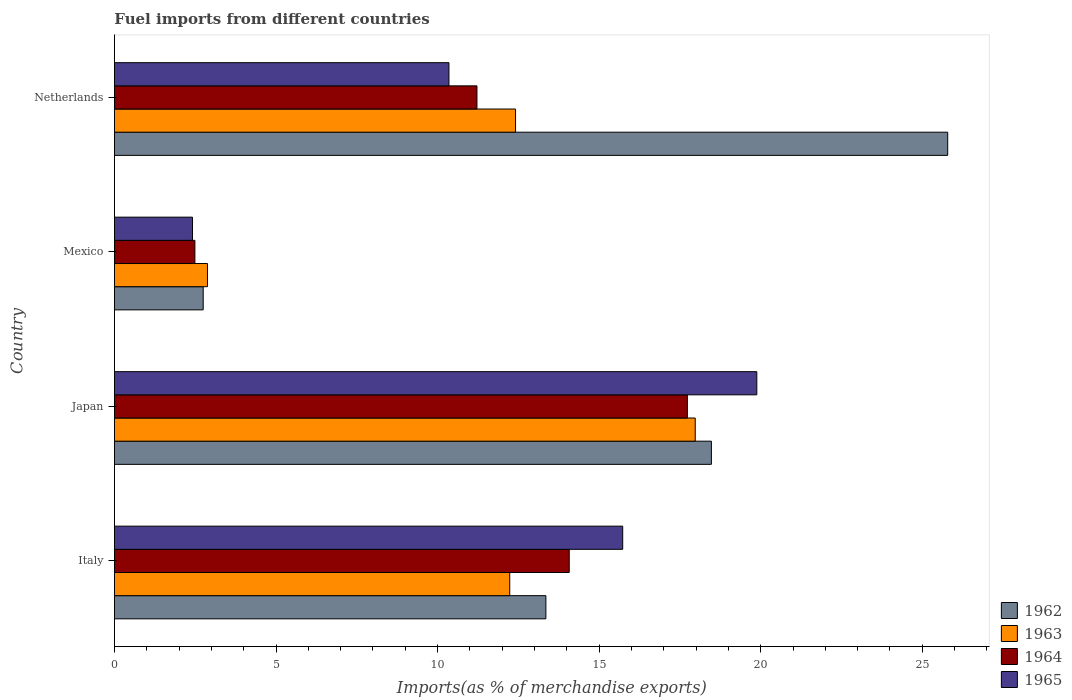What is the percentage of imports to different countries in 1964 in Netherlands?
Offer a very short reply. 11.22. Across all countries, what is the maximum percentage of imports to different countries in 1962?
Your answer should be compact. 25.79. Across all countries, what is the minimum percentage of imports to different countries in 1962?
Offer a terse response. 2.75. In which country was the percentage of imports to different countries in 1963 minimum?
Your answer should be compact. Mexico. What is the total percentage of imports to different countries in 1965 in the graph?
Provide a short and direct response. 48.38. What is the difference between the percentage of imports to different countries in 1963 in Italy and that in Japan?
Keep it short and to the point. -5.74. What is the difference between the percentage of imports to different countries in 1963 in Italy and the percentage of imports to different countries in 1965 in Netherlands?
Your answer should be compact. 1.88. What is the average percentage of imports to different countries in 1962 per country?
Offer a terse response. 15.09. What is the difference between the percentage of imports to different countries in 1963 and percentage of imports to different countries in 1962 in Netherlands?
Make the answer very short. -13.37. What is the ratio of the percentage of imports to different countries in 1962 in Italy to that in Japan?
Give a very brief answer. 0.72. What is the difference between the highest and the second highest percentage of imports to different countries in 1965?
Your answer should be very brief. 4.15. What is the difference between the highest and the lowest percentage of imports to different countries in 1965?
Provide a succinct answer. 17.46. Is the sum of the percentage of imports to different countries in 1963 in Japan and Netherlands greater than the maximum percentage of imports to different countries in 1964 across all countries?
Your answer should be compact. Yes. What does the 4th bar from the top in Japan represents?
Provide a succinct answer. 1962. What does the 3rd bar from the bottom in Italy represents?
Give a very brief answer. 1964. Is it the case that in every country, the sum of the percentage of imports to different countries in 1964 and percentage of imports to different countries in 1962 is greater than the percentage of imports to different countries in 1965?
Provide a succinct answer. Yes. How many bars are there?
Offer a very short reply. 16. Are all the bars in the graph horizontal?
Offer a very short reply. Yes. What is the difference between two consecutive major ticks on the X-axis?
Make the answer very short. 5. Are the values on the major ticks of X-axis written in scientific E-notation?
Provide a short and direct response. No. What is the title of the graph?
Your response must be concise. Fuel imports from different countries. Does "1997" appear as one of the legend labels in the graph?
Provide a succinct answer. No. What is the label or title of the X-axis?
Offer a terse response. Imports(as % of merchandise exports). What is the label or title of the Y-axis?
Ensure brevity in your answer.  Country. What is the Imports(as % of merchandise exports) of 1962 in Italy?
Make the answer very short. 13.35. What is the Imports(as % of merchandise exports) in 1963 in Italy?
Offer a terse response. 12.23. What is the Imports(as % of merchandise exports) in 1964 in Italy?
Your answer should be very brief. 14.07. What is the Imports(as % of merchandise exports) in 1965 in Italy?
Offer a terse response. 15.73. What is the Imports(as % of merchandise exports) in 1962 in Japan?
Your answer should be compact. 18.47. What is the Imports(as % of merchandise exports) in 1963 in Japan?
Provide a short and direct response. 17.97. What is the Imports(as % of merchandise exports) in 1964 in Japan?
Offer a very short reply. 17.73. What is the Imports(as % of merchandise exports) in 1965 in Japan?
Keep it short and to the point. 19.88. What is the Imports(as % of merchandise exports) of 1962 in Mexico?
Your answer should be very brief. 2.75. What is the Imports(as % of merchandise exports) in 1963 in Mexico?
Your answer should be very brief. 2.88. What is the Imports(as % of merchandise exports) in 1964 in Mexico?
Your answer should be compact. 2.49. What is the Imports(as % of merchandise exports) of 1965 in Mexico?
Make the answer very short. 2.42. What is the Imports(as % of merchandise exports) in 1962 in Netherlands?
Provide a succinct answer. 25.79. What is the Imports(as % of merchandise exports) of 1963 in Netherlands?
Offer a terse response. 12.41. What is the Imports(as % of merchandise exports) in 1964 in Netherlands?
Keep it short and to the point. 11.22. What is the Imports(as % of merchandise exports) of 1965 in Netherlands?
Your answer should be very brief. 10.35. Across all countries, what is the maximum Imports(as % of merchandise exports) of 1962?
Ensure brevity in your answer.  25.79. Across all countries, what is the maximum Imports(as % of merchandise exports) in 1963?
Your response must be concise. 17.97. Across all countries, what is the maximum Imports(as % of merchandise exports) in 1964?
Give a very brief answer. 17.73. Across all countries, what is the maximum Imports(as % of merchandise exports) of 1965?
Your response must be concise. 19.88. Across all countries, what is the minimum Imports(as % of merchandise exports) in 1962?
Offer a terse response. 2.75. Across all countries, what is the minimum Imports(as % of merchandise exports) in 1963?
Keep it short and to the point. 2.88. Across all countries, what is the minimum Imports(as % of merchandise exports) in 1964?
Make the answer very short. 2.49. Across all countries, what is the minimum Imports(as % of merchandise exports) in 1965?
Your answer should be very brief. 2.42. What is the total Imports(as % of merchandise exports) in 1962 in the graph?
Provide a short and direct response. 60.36. What is the total Imports(as % of merchandise exports) in 1963 in the graph?
Offer a very short reply. 45.5. What is the total Imports(as % of merchandise exports) in 1964 in the graph?
Offer a very short reply. 45.52. What is the total Imports(as % of merchandise exports) in 1965 in the graph?
Offer a very short reply. 48.38. What is the difference between the Imports(as % of merchandise exports) of 1962 in Italy and that in Japan?
Ensure brevity in your answer.  -5.12. What is the difference between the Imports(as % of merchandise exports) of 1963 in Italy and that in Japan?
Offer a very short reply. -5.74. What is the difference between the Imports(as % of merchandise exports) in 1964 in Italy and that in Japan?
Your answer should be very brief. -3.66. What is the difference between the Imports(as % of merchandise exports) in 1965 in Italy and that in Japan?
Your answer should be compact. -4.15. What is the difference between the Imports(as % of merchandise exports) in 1962 in Italy and that in Mexico?
Make the answer very short. 10.61. What is the difference between the Imports(as % of merchandise exports) of 1963 in Italy and that in Mexico?
Give a very brief answer. 9.36. What is the difference between the Imports(as % of merchandise exports) in 1964 in Italy and that in Mexico?
Provide a short and direct response. 11.58. What is the difference between the Imports(as % of merchandise exports) in 1965 in Italy and that in Mexico?
Give a very brief answer. 13.31. What is the difference between the Imports(as % of merchandise exports) of 1962 in Italy and that in Netherlands?
Offer a terse response. -12.44. What is the difference between the Imports(as % of merchandise exports) of 1963 in Italy and that in Netherlands?
Your answer should be very brief. -0.18. What is the difference between the Imports(as % of merchandise exports) of 1964 in Italy and that in Netherlands?
Your answer should be compact. 2.86. What is the difference between the Imports(as % of merchandise exports) in 1965 in Italy and that in Netherlands?
Make the answer very short. 5.38. What is the difference between the Imports(as % of merchandise exports) in 1962 in Japan and that in Mexico?
Your answer should be compact. 15.73. What is the difference between the Imports(as % of merchandise exports) of 1963 in Japan and that in Mexico?
Your response must be concise. 15.1. What is the difference between the Imports(as % of merchandise exports) of 1964 in Japan and that in Mexico?
Make the answer very short. 15.24. What is the difference between the Imports(as % of merchandise exports) in 1965 in Japan and that in Mexico?
Provide a succinct answer. 17.46. What is the difference between the Imports(as % of merchandise exports) in 1962 in Japan and that in Netherlands?
Make the answer very short. -7.31. What is the difference between the Imports(as % of merchandise exports) in 1963 in Japan and that in Netherlands?
Keep it short and to the point. 5.56. What is the difference between the Imports(as % of merchandise exports) of 1964 in Japan and that in Netherlands?
Offer a very short reply. 6.51. What is the difference between the Imports(as % of merchandise exports) of 1965 in Japan and that in Netherlands?
Offer a very short reply. 9.53. What is the difference between the Imports(as % of merchandise exports) in 1962 in Mexico and that in Netherlands?
Provide a short and direct response. -23.04. What is the difference between the Imports(as % of merchandise exports) in 1963 in Mexico and that in Netherlands?
Provide a short and direct response. -9.53. What is the difference between the Imports(as % of merchandise exports) in 1964 in Mexico and that in Netherlands?
Your answer should be very brief. -8.73. What is the difference between the Imports(as % of merchandise exports) of 1965 in Mexico and that in Netherlands?
Offer a terse response. -7.94. What is the difference between the Imports(as % of merchandise exports) of 1962 in Italy and the Imports(as % of merchandise exports) of 1963 in Japan?
Your answer should be very brief. -4.62. What is the difference between the Imports(as % of merchandise exports) in 1962 in Italy and the Imports(as % of merchandise exports) in 1964 in Japan?
Give a very brief answer. -4.38. What is the difference between the Imports(as % of merchandise exports) of 1962 in Italy and the Imports(as % of merchandise exports) of 1965 in Japan?
Make the answer very short. -6.53. What is the difference between the Imports(as % of merchandise exports) of 1963 in Italy and the Imports(as % of merchandise exports) of 1964 in Japan?
Ensure brevity in your answer.  -5.5. What is the difference between the Imports(as % of merchandise exports) of 1963 in Italy and the Imports(as % of merchandise exports) of 1965 in Japan?
Make the answer very short. -7.65. What is the difference between the Imports(as % of merchandise exports) in 1964 in Italy and the Imports(as % of merchandise exports) in 1965 in Japan?
Provide a succinct answer. -5.8. What is the difference between the Imports(as % of merchandise exports) of 1962 in Italy and the Imports(as % of merchandise exports) of 1963 in Mexico?
Keep it short and to the point. 10.47. What is the difference between the Imports(as % of merchandise exports) of 1962 in Italy and the Imports(as % of merchandise exports) of 1964 in Mexico?
Your answer should be very brief. 10.86. What is the difference between the Imports(as % of merchandise exports) in 1962 in Italy and the Imports(as % of merchandise exports) in 1965 in Mexico?
Your answer should be very brief. 10.94. What is the difference between the Imports(as % of merchandise exports) of 1963 in Italy and the Imports(as % of merchandise exports) of 1964 in Mexico?
Make the answer very short. 9.74. What is the difference between the Imports(as % of merchandise exports) in 1963 in Italy and the Imports(as % of merchandise exports) in 1965 in Mexico?
Give a very brief answer. 9.82. What is the difference between the Imports(as % of merchandise exports) in 1964 in Italy and the Imports(as % of merchandise exports) in 1965 in Mexico?
Offer a terse response. 11.66. What is the difference between the Imports(as % of merchandise exports) of 1962 in Italy and the Imports(as % of merchandise exports) of 1963 in Netherlands?
Provide a short and direct response. 0.94. What is the difference between the Imports(as % of merchandise exports) in 1962 in Italy and the Imports(as % of merchandise exports) in 1964 in Netherlands?
Make the answer very short. 2.13. What is the difference between the Imports(as % of merchandise exports) in 1962 in Italy and the Imports(as % of merchandise exports) in 1965 in Netherlands?
Your answer should be compact. 3. What is the difference between the Imports(as % of merchandise exports) in 1963 in Italy and the Imports(as % of merchandise exports) in 1964 in Netherlands?
Your answer should be very brief. 1.01. What is the difference between the Imports(as % of merchandise exports) of 1963 in Italy and the Imports(as % of merchandise exports) of 1965 in Netherlands?
Your answer should be very brief. 1.88. What is the difference between the Imports(as % of merchandise exports) in 1964 in Italy and the Imports(as % of merchandise exports) in 1965 in Netherlands?
Give a very brief answer. 3.72. What is the difference between the Imports(as % of merchandise exports) of 1962 in Japan and the Imports(as % of merchandise exports) of 1963 in Mexico?
Keep it short and to the point. 15.6. What is the difference between the Imports(as % of merchandise exports) in 1962 in Japan and the Imports(as % of merchandise exports) in 1964 in Mexico?
Your response must be concise. 15.98. What is the difference between the Imports(as % of merchandise exports) of 1962 in Japan and the Imports(as % of merchandise exports) of 1965 in Mexico?
Make the answer very short. 16.06. What is the difference between the Imports(as % of merchandise exports) in 1963 in Japan and the Imports(as % of merchandise exports) in 1964 in Mexico?
Give a very brief answer. 15.48. What is the difference between the Imports(as % of merchandise exports) of 1963 in Japan and the Imports(as % of merchandise exports) of 1965 in Mexico?
Your answer should be compact. 15.56. What is the difference between the Imports(as % of merchandise exports) in 1964 in Japan and the Imports(as % of merchandise exports) in 1965 in Mexico?
Offer a terse response. 15.32. What is the difference between the Imports(as % of merchandise exports) of 1962 in Japan and the Imports(as % of merchandise exports) of 1963 in Netherlands?
Provide a short and direct response. 6.06. What is the difference between the Imports(as % of merchandise exports) of 1962 in Japan and the Imports(as % of merchandise exports) of 1964 in Netherlands?
Your answer should be very brief. 7.25. What is the difference between the Imports(as % of merchandise exports) of 1962 in Japan and the Imports(as % of merchandise exports) of 1965 in Netherlands?
Offer a terse response. 8.12. What is the difference between the Imports(as % of merchandise exports) in 1963 in Japan and the Imports(as % of merchandise exports) in 1964 in Netherlands?
Your response must be concise. 6.76. What is the difference between the Imports(as % of merchandise exports) in 1963 in Japan and the Imports(as % of merchandise exports) in 1965 in Netherlands?
Your response must be concise. 7.62. What is the difference between the Imports(as % of merchandise exports) in 1964 in Japan and the Imports(as % of merchandise exports) in 1965 in Netherlands?
Your answer should be very brief. 7.38. What is the difference between the Imports(as % of merchandise exports) in 1962 in Mexico and the Imports(as % of merchandise exports) in 1963 in Netherlands?
Your answer should be very brief. -9.67. What is the difference between the Imports(as % of merchandise exports) in 1962 in Mexico and the Imports(as % of merchandise exports) in 1964 in Netherlands?
Offer a very short reply. -8.47. What is the difference between the Imports(as % of merchandise exports) in 1962 in Mexico and the Imports(as % of merchandise exports) in 1965 in Netherlands?
Your response must be concise. -7.61. What is the difference between the Imports(as % of merchandise exports) in 1963 in Mexico and the Imports(as % of merchandise exports) in 1964 in Netherlands?
Ensure brevity in your answer.  -8.34. What is the difference between the Imports(as % of merchandise exports) in 1963 in Mexico and the Imports(as % of merchandise exports) in 1965 in Netherlands?
Provide a succinct answer. -7.47. What is the difference between the Imports(as % of merchandise exports) in 1964 in Mexico and the Imports(as % of merchandise exports) in 1965 in Netherlands?
Keep it short and to the point. -7.86. What is the average Imports(as % of merchandise exports) of 1962 per country?
Offer a terse response. 15.09. What is the average Imports(as % of merchandise exports) in 1963 per country?
Provide a succinct answer. 11.38. What is the average Imports(as % of merchandise exports) of 1964 per country?
Offer a terse response. 11.38. What is the average Imports(as % of merchandise exports) in 1965 per country?
Give a very brief answer. 12.09. What is the difference between the Imports(as % of merchandise exports) of 1962 and Imports(as % of merchandise exports) of 1963 in Italy?
Make the answer very short. 1.12. What is the difference between the Imports(as % of merchandise exports) in 1962 and Imports(as % of merchandise exports) in 1964 in Italy?
Offer a terse response. -0.72. What is the difference between the Imports(as % of merchandise exports) in 1962 and Imports(as % of merchandise exports) in 1965 in Italy?
Keep it short and to the point. -2.38. What is the difference between the Imports(as % of merchandise exports) of 1963 and Imports(as % of merchandise exports) of 1964 in Italy?
Offer a terse response. -1.84. What is the difference between the Imports(as % of merchandise exports) in 1963 and Imports(as % of merchandise exports) in 1965 in Italy?
Your answer should be compact. -3.5. What is the difference between the Imports(as % of merchandise exports) of 1964 and Imports(as % of merchandise exports) of 1965 in Italy?
Your answer should be compact. -1.65. What is the difference between the Imports(as % of merchandise exports) in 1962 and Imports(as % of merchandise exports) in 1963 in Japan?
Your response must be concise. 0.5. What is the difference between the Imports(as % of merchandise exports) in 1962 and Imports(as % of merchandise exports) in 1964 in Japan?
Ensure brevity in your answer.  0.74. What is the difference between the Imports(as % of merchandise exports) in 1962 and Imports(as % of merchandise exports) in 1965 in Japan?
Your answer should be compact. -1.41. What is the difference between the Imports(as % of merchandise exports) of 1963 and Imports(as % of merchandise exports) of 1964 in Japan?
Provide a succinct answer. 0.24. What is the difference between the Imports(as % of merchandise exports) in 1963 and Imports(as % of merchandise exports) in 1965 in Japan?
Give a very brief answer. -1.91. What is the difference between the Imports(as % of merchandise exports) of 1964 and Imports(as % of merchandise exports) of 1965 in Japan?
Provide a succinct answer. -2.15. What is the difference between the Imports(as % of merchandise exports) in 1962 and Imports(as % of merchandise exports) in 1963 in Mexico?
Provide a succinct answer. -0.13. What is the difference between the Imports(as % of merchandise exports) of 1962 and Imports(as % of merchandise exports) of 1964 in Mexico?
Give a very brief answer. 0.26. What is the difference between the Imports(as % of merchandise exports) in 1962 and Imports(as % of merchandise exports) in 1965 in Mexico?
Ensure brevity in your answer.  0.33. What is the difference between the Imports(as % of merchandise exports) in 1963 and Imports(as % of merchandise exports) in 1964 in Mexico?
Provide a short and direct response. 0.39. What is the difference between the Imports(as % of merchandise exports) of 1963 and Imports(as % of merchandise exports) of 1965 in Mexico?
Ensure brevity in your answer.  0.46. What is the difference between the Imports(as % of merchandise exports) of 1964 and Imports(as % of merchandise exports) of 1965 in Mexico?
Provide a short and direct response. 0.07. What is the difference between the Imports(as % of merchandise exports) in 1962 and Imports(as % of merchandise exports) in 1963 in Netherlands?
Offer a terse response. 13.37. What is the difference between the Imports(as % of merchandise exports) of 1962 and Imports(as % of merchandise exports) of 1964 in Netherlands?
Offer a terse response. 14.57. What is the difference between the Imports(as % of merchandise exports) of 1962 and Imports(as % of merchandise exports) of 1965 in Netherlands?
Your answer should be compact. 15.43. What is the difference between the Imports(as % of merchandise exports) in 1963 and Imports(as % of merchandise exports) in 1964 in Netherlands?
Make the answer very short. 1.19. What is the difference between the Imports(as % of merchandise exports) of 1963 and Imports(as % of merchandise exports) of 1965 in Netherlands?
Give a very brief answer. 2.06. What is the difference between the Imports(as % of merchandise exports) in 1964 and Imports(as % of merchandise exports) in 1965 in Netherlands?
Make the answer very short. 0.87. What is the ratio of the Imports(as % of merchandise exports) in 1962 in Italy to that in Japan?
Your answer should be very brief. 0.72. What is the ratio of the Imports(as % of merchandise exports) in 1963 in Italy to that in Japan?
Provide a succinct answer. 0.68. What is the ratio of the Imports(as % of merchandise exports) of 1964 in Italy to that in Japan?
Make the answer very short. 0.79. What is the ratio of the Imports(as % of merchandise exports) of 1965 in Italy to that in Japan?
Give a very brief answer. 0.79. What is the ratio of the Imports(as % of merchandise exports) in 1962 in Italy to that in Mexico?
Make the answer very short. 4.86. What is the ratio of the Imports(as % of merchandise exports) in 1963 in Italy to that in Mexico?
Make the answer very short. 4.25. What is the ratio of the Imports(as % of merchandise exports) in 1964 in Italy to that in Mexico?
Your response must be concise. 5.65. What is the ratio of the Imports(as % of merchandise exports) in 1965 in Italy to that in Mexico?
Make the answer very short. 6.51. What is the ratio of the Imports(as % of merchandise exports) of 1962 in Italy to that in Netherlands?
Ensure brevity in your answer.  0.52. What is the ratio of the Imports(as % of merchandise exports) in 1963 in Italy to that in Netherlands?
Make the answer very short. 0.99. What is the ratio of the Imports(as % of merchandise exports) in 1964 in Italy to that in Netherlands?
Give a very brief answer. 1.25. What is the ratio of the Imports(as % of merchandise exports) of 1965 in Italy to that in Netherlands?
Your answer should be compact. 1.52. What is the ratio of the Imports(as % of merchandise exports) in 1962 in Japan to that in Mexico?
Provide a succinct answer. 6.72. What is the ratio of the Imports(as % of merchandise exports) of 1963 in Japan to that in Mexico?
Your response must be concise. 6.24. What is the ratio of the Imports(as % of merchandise exports) of 1964 in Japan to that in Mexico?
Give a very brief answer. 7.12. What is the ratio of the Imports(as % of merchandise exports) of 1965 in Japan to that in Mexico?
Provide a succinct answer. 8.23. What is the ratio of the Imports(as % of merchandise exports) in 1962 in Japan to that in Netherlands?
Offer a terse response. 0.72. What is the ratio of the Imports(as % of merchandise exports) in 1963 in Japan to that in Netherlands?
Keep it short and to the point. 1.45. What is the ratio of the Imports(as % of merchandise exports) in 1964 in Japan to that in Netherlands?
Provide a short and direct response. 1.58. What is the ratio of the Imports(as % of merchandise exports) in 1965 in Japan to that in Netherlands?
Keep it short and to the point. 1.92. What is the ratio of the Imports(as % of merchandise exports) of 1962 in Mexico to that in Netherlands?
Ensure brevity in your answer.  0.11. What is the ratio of the Imports(as % of merchandise exports) of 1963 in Mexico to that in Netherlands?
Your response must be concise. 0.23. What is the ratio of the Imports(as % of merchandise exports) in 1964 in Mexico to that in Netherlands?
Provide a short and direct response. 0.22. What is the ratio of the Imports(as % of merchandise exports) in 1965 in Mexico to that in Netherlands?
Give a very brief answer. 0.23. What is the difference between the highest and the second highest Imports(as % of merchandise exports) of 1962?
Give a very brief answer. 7.31. What is the difference between the highest and the second highest Imports(as % of merchandise exports) of 1963?
Your answer should be very brief. 5.56. What is the difference between the highest and the second highest Imports(as % of merchandise exports) of 1964?
Make the answer very short. 3.66. What is the difference between the highest and the second highest Imports(as % of merchandise exports) in 1965?
Your answer should be compact. 4.15. What is the difference between the highest and the lowest Imports(as % of merchandise exports) of 1962?
Make the answer very short. 23.04. What is the difference between the highest and the lowest Imports(as % of merchandise exports) in 1963?
Give a very brief answer. 15.1. What is the difference between the highest and the lowest Imports(as % of merchandise exports) of 1964?
Give a very brief answer. 15.24. What is the difference between the highest and the lowest Imports(as % of merchandise exports) in 1965?
Offer a very short reply. 17.46. 